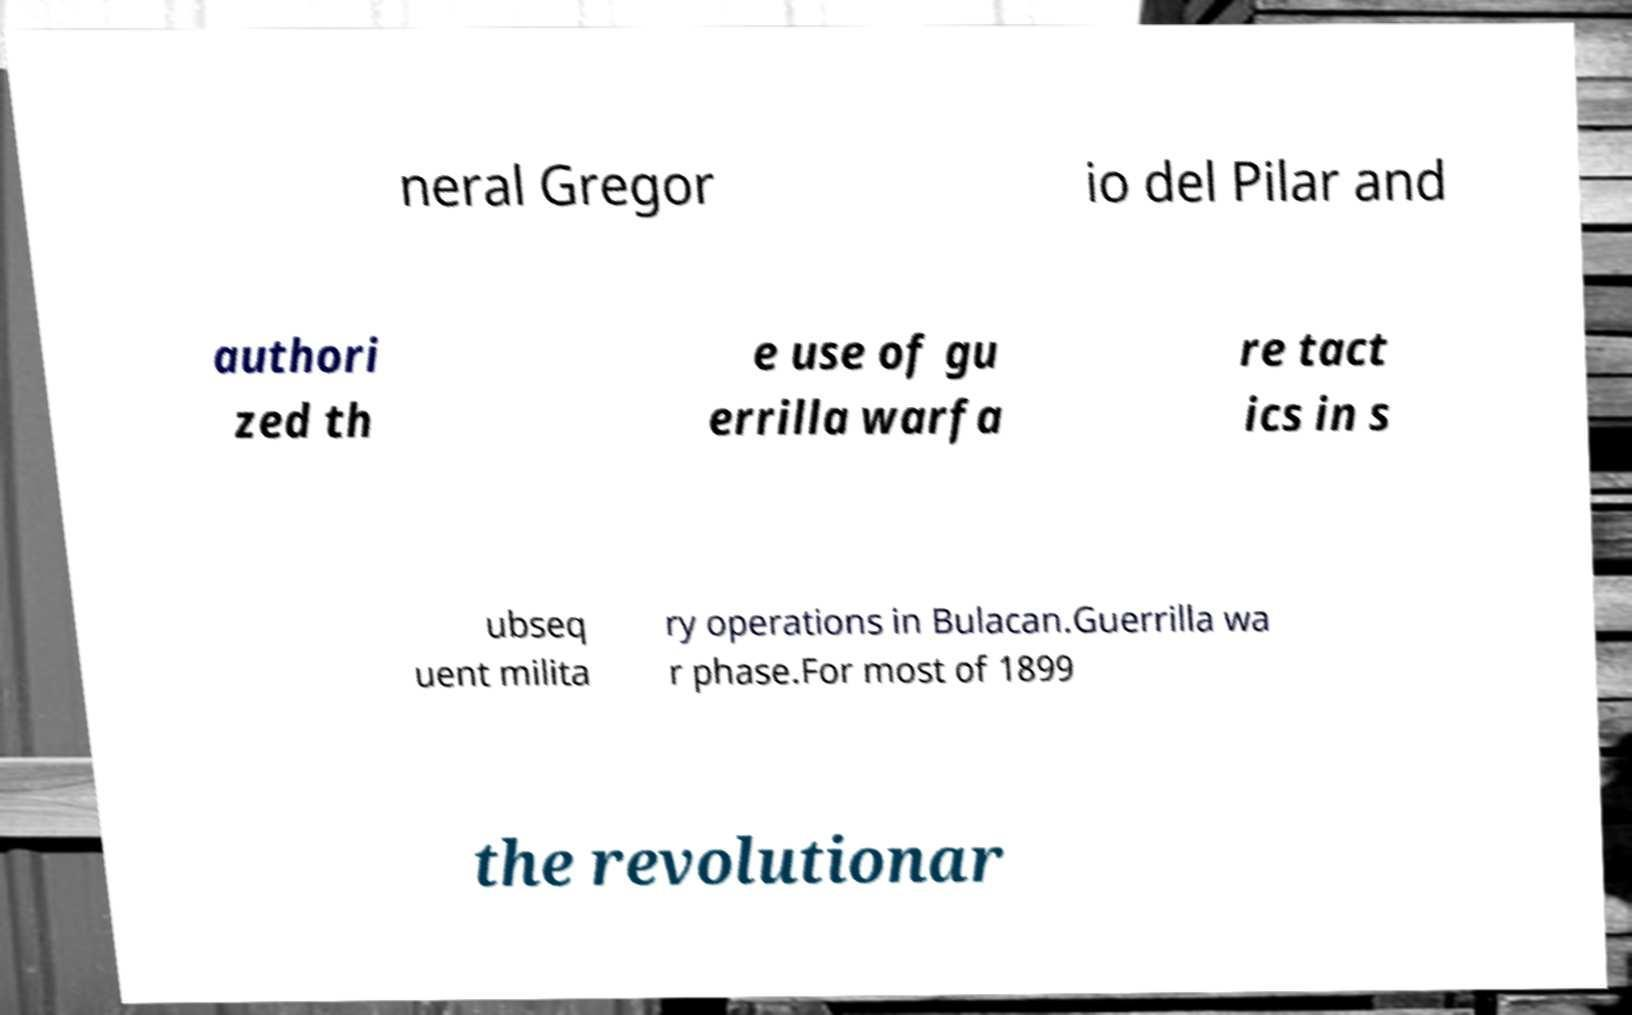Please identify and transcribe the text found in this image. neral Gregor io del Pilar and authori zed th e use of gu errilla warfa re tact ics in s ubseq uent milita ry operations in Bulacan.Guerrilla wa r phase.For most of 1899 the revolutionar 